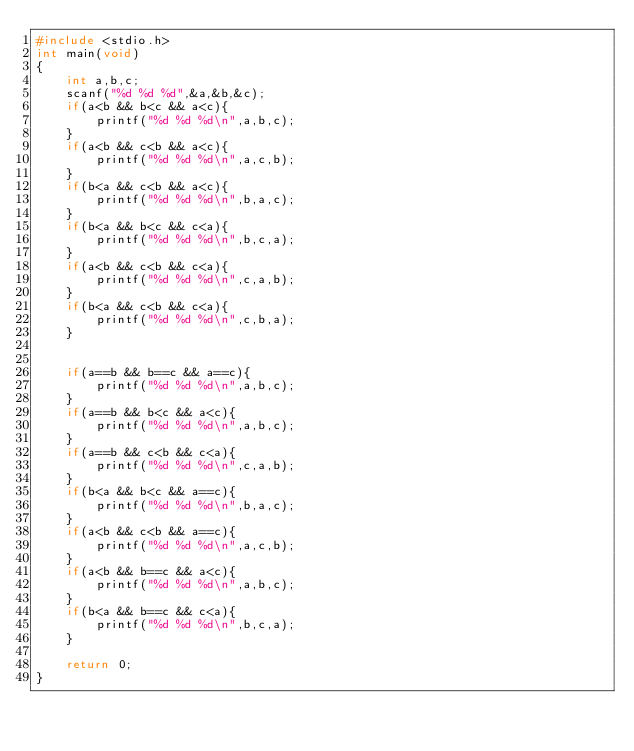<code> <loc_0><loc_0><loc_500><loc_500><_C_>#include <stdio.h>
int main(void)
{
	int a,b,c;
	scanf("%d %d %d",&a,&b,&c);
	if(a<b && b<c && a<c){
		printf("%d %d %d\n",a,b,c);
	}
	if(a<b && c<b && a<c){
		printf("%d %d %d\n",a,c,b);
	}
	if(b<a && c<b && a<c){
		printf("%d %d %d\n",b,a,c);
	}
	if(b<a && b<c && c<a){
		printf("%d %d %d\n",b,c,a);
	}
	if(a<b && c<b && c<a){
		printf("%d %d %d\n",c,a,b);
	}
	if(b<a && c<b && c<a){
		printf("%d %d %d\n",c,b,a);
	}


	if(a==b && b==c && a==c){
		printf("%d %d %d\n",a,b,c);
	}
	if(a==b && b<c && a<c){
		printf("%d %d %d\n",a,b,c);
	}
	if(a==b && c<b && c<a){
		printf("%d %d %d\n",c,a,b);
	}
	if(b<a && b<c && a==c){
		printf("%d %d %d\n",b,a,c);
	}
	if(a<b && c<b && a==c){
		printf("%d %d %d\n",a,c,b);
	}
	if(a<b && b==c && a<c){
		printf("%d %d %d\n",a,b,c);
	}
	if(b<a && b==c && c<a){
		printf("%d %d %d\n",b,c,a);
	}

	return 0;
}
</code> 